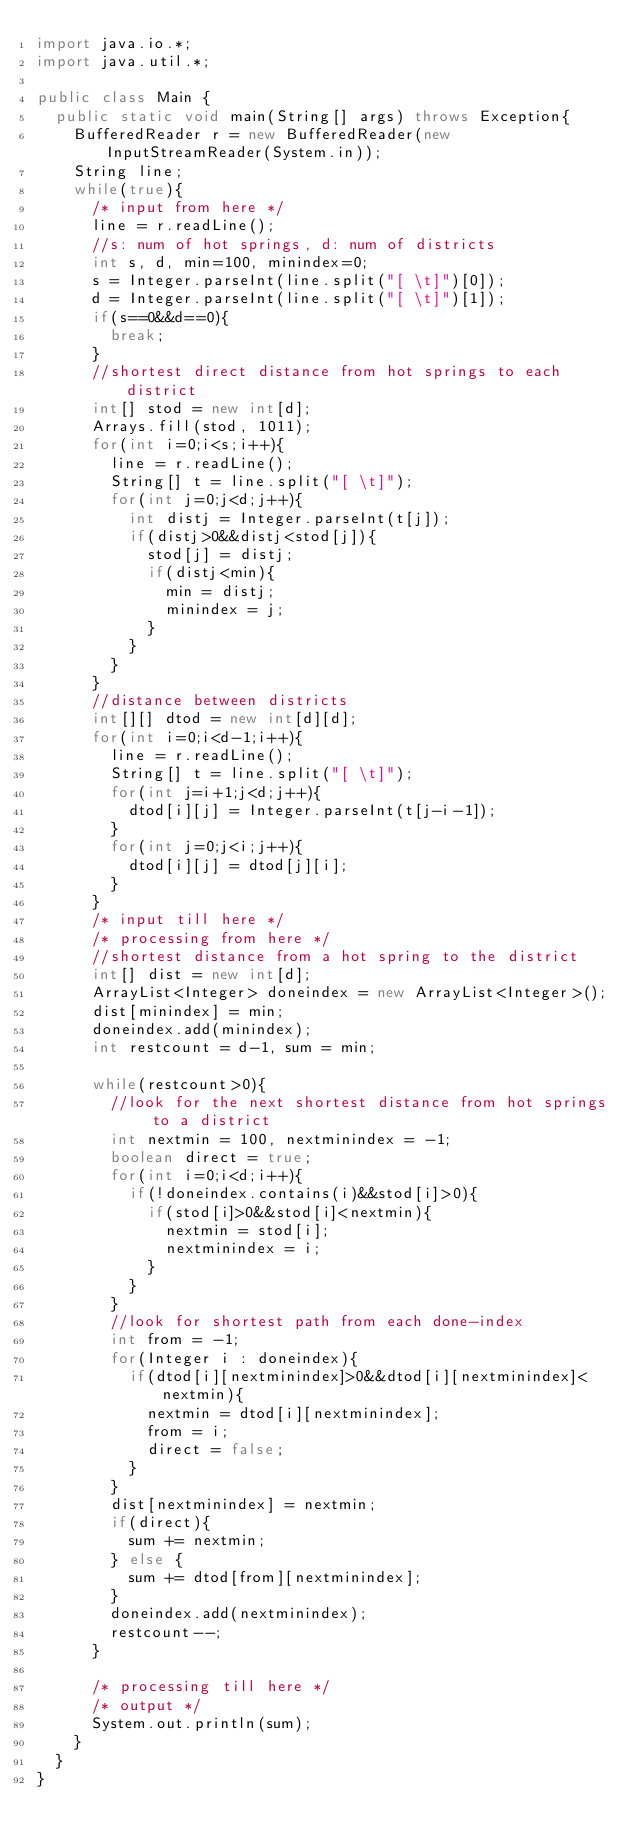<code> <loc_0><loc_0><loc_500><loc_500><_Java_>import java.io.*;
import java.util.*;

public class Main {
	public static void main(String[] args) throws Exception{
		BufferedReader r = new BufferedReader(new InputStreamReader(System.in));
		String line;
		while(true){
			/* input from here */
			line = r.readLine();
			//s: num of hot springs, d: num of districts
			int s, d, min=100, minindex=0;
			s = Integer.parseInt(line.split("[ \t]")[0]);
			d = Integer.parseInt(line.split("[ \t]")[1]);
			if(s==0&&d==0){
				break;
			}
			//shortest direct distance from hot springs to each district
			int[] stod = new int[d];
			Arrays.fill(stod, 1011);
			for(int i=0;i<s;i++){
				line = r.readLine();
				String[] t = line.split("[ \t]");
				for(int j=0;j<d;j++){
					int distj = Integer.parseInt(t[j]);
					if(distj>0&&distj<stod[j]){
						stod[j] = distj;
						if(distj<min){
							min = distj;
							minindex = j;
						}
					}
				}
			}
			//distance between districts
			int[][] dtod = new int[d][d];
			for(int i=0;i<d-1;i++){
				line = r.readLine();
				String[] t = line.split("[ \t]");
				for(int j=i+1;j<d;j++){
					dtod[i][j] = Integer.parseInt(t[j-i-1]);
				}
				for(int j=0;j<i;j++){
					dtod[i][j] = dtod[j][i];
				}
			}				
			/* input till here */
			/* processing from here */
			//shortest distance from a hot spring to the district 
			int[] dist = new int[d];
			ArrayList<Integer> doneindex = new ArrayList<Integer>();
			dist[minindex] = min;
			doneindex.add(minindex);
			int restcount = d-1, sum = min;

			while(restcount>0){
				//look for the next shortest distance from hot springs to a district
				int nextmin = 100, nextminindex = -1;
				boolean direct = true;
				for(int i=0;i<d;i++){
					if(!doneindex.contains(i)&&stod[i]>0){
						if(stod[i]>0&&stod[i]<nextmin){
							nextmin = stod[i];
							nextminindex = i;
						}
					}
				}
				//look for shortest path from each done-index
				int from = -1;
				for(Integer i : doneindex){
					if(dtod[i][nextminindex]>0&&dtod[i][nextminindex]<nextmin){
						nextmin = dtod[i][nextminindex];
						from = i;
						direct = false;
					}
				}
				dist[nextminindex] = nextmin;
				if(direct){
					sum += nextmin;
				} else {
					sum += dtod[from][nextminindex];
				}
				doneindex.add(nextminindex);
				restcount--;
			}

			/* processing till here */
			/* output */
			System.out.println(sum);
		}
	}
}</code> 